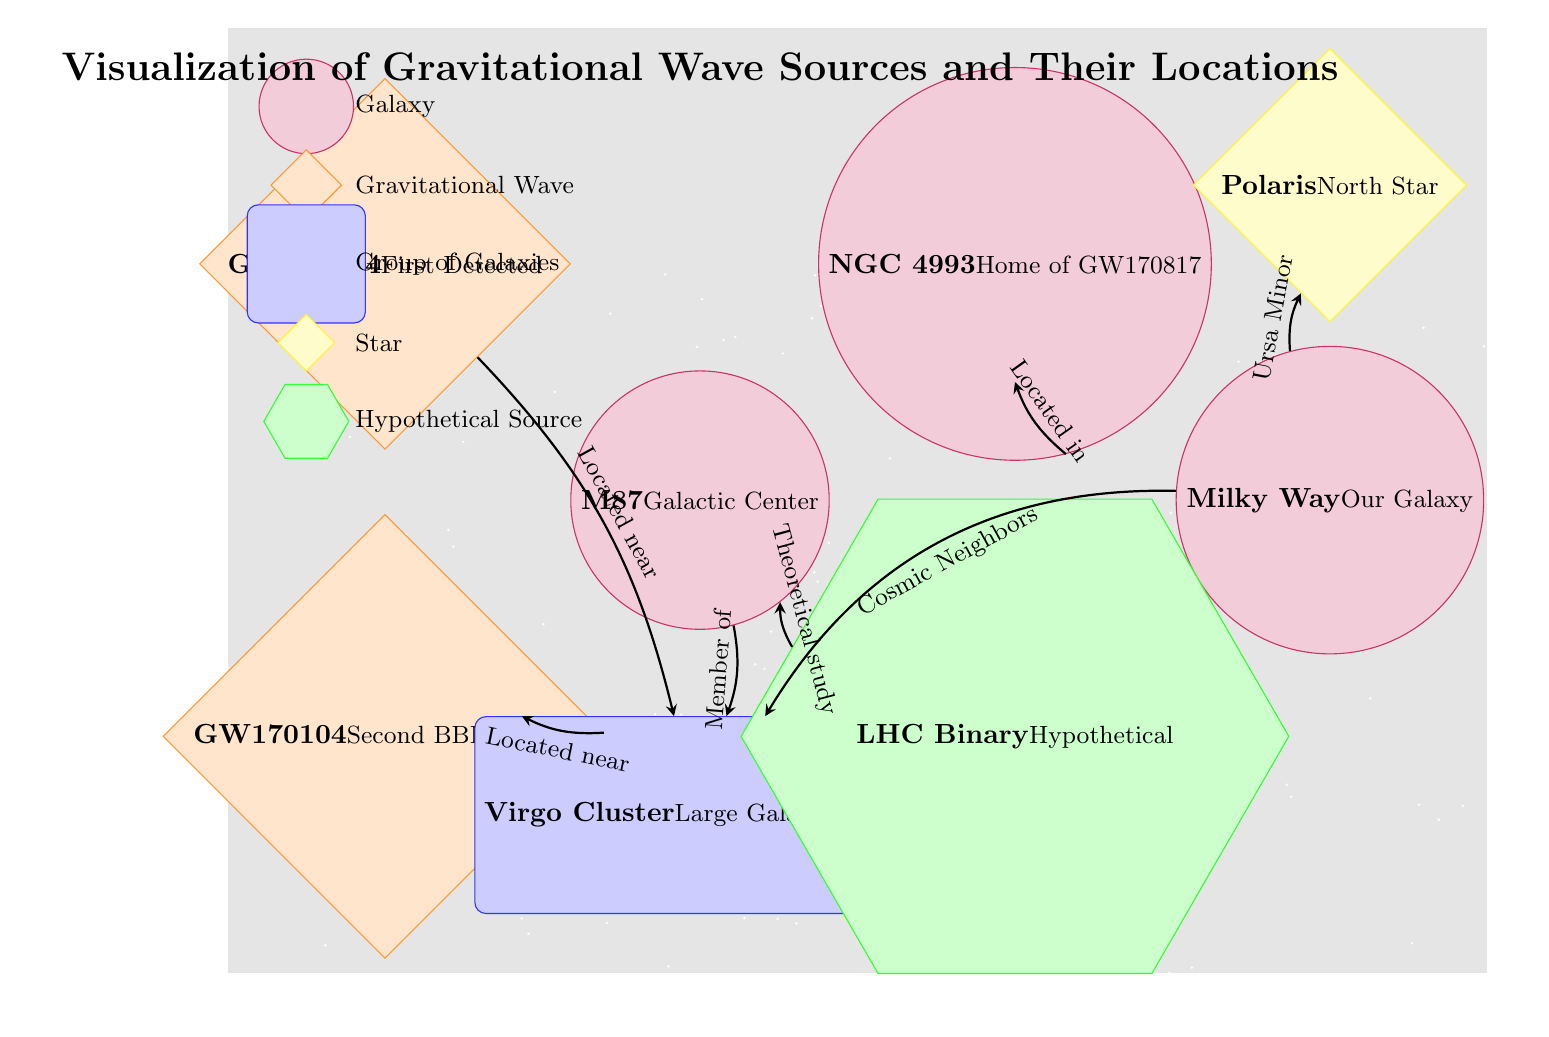What is the central galaxy depicted in the diagram? The diagram indicates M87 as the central galaxy, which is specifically labeled at the origin (0,0) coordinates.
Answer: M87 How many gravitational wave sources are represented? There are three gravitational wave sources in the diagram: GW150914, GW170104, and LHC Binary. Counting these, we confirm there are three distinct sources identified by the star shapes.
Answer: 3 Which galaxy is home to GW170817? The diagram shows that GW170817 is located in the galaxy NGC 4993, which is clearly labeled near the corresponding star node representing GW170817.
Answer: NGC 4993 What direction does GW150914 have an edge leading to? The edge from GW150914 leads downwards to the Virgos group, which labels its interaction as "Located near" and is positioned directly below GW150914.
Answer: Virgo Is there a hypothetical gravitational wave source listed in the diagram? Yes, there is a hypothetical gravitational wave source indicated as LHC Binary, specifically noted with a green hexagon shape in the lower part of the diagram.
Answer: LHC Binary Which galaxy is mentioned as our own? The diagram identifies the Milky Way as our own galaxy, which is marked on the right side labeled "Our Galaxy."
Answer: Milky Way How many groups of galaxies are shown in the diagram? The diagram indicates there is one group of galaxies represented, specifically the Virgo Cluster, which is labeled as a rectangle shape at the bottom.
Answer: 1 Which star is depicted as the North Star? Polaris is identified in the diagram as the North Star and is represented by a diamond shape in the upper right quadrant of the diagram.
Answer: Polaris What does the edge labeled "Located in" connect to? The edge labeled "Located in" connects NGC 4993 to a general area above it within the diagram, represented as the point (4,1.5).
Answer: Point (4,1.5) 